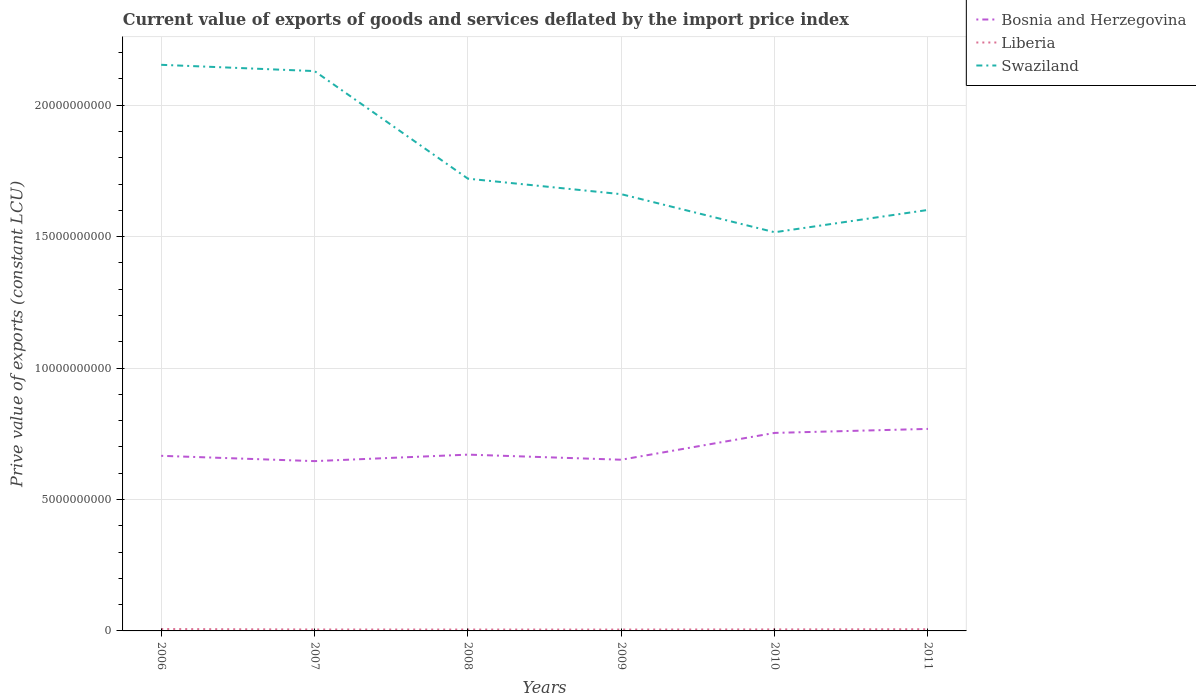How many different coloured lines are there?
Your answer should be compact. 3. Across all years, what is the maximum prive value of exports in Bosnia and Herzegovina?
Keep it short and to the point. 6.46e+09. What is the total prive value of exports in Swaziland in the graph?
Your response must be concise. 6.37e+09. What is the difference between the highest and the second highest prive value of exports in Swaziland?
Ensure brevity in your answer.  6.37e+09. What is the difference between the highest and the lowest prive value of exports in Bosnia and Herzegovina?
Make the answer very short. 2. Is the prive value of exports in Bosnia and Herzegovina strictly greater than the prive value of exports in Liberia over the years?
Provide a short and direct response. No. How many lines are there?
Give a very brief answer. 3. How many years are there in the graph?
Your answer should be very brief. 6. What is the difference between two consecutive major ticks on the Y-axis?
Your answer should be compact. 5.00e+09. Does the graph contain any zero values?
Provide a succinct answer. No. Where does the legend appear in the graph?
Offer a terse response. Top right. How many legend labels are there?
Your answer should be compact. 3. What is the title of the graph?
Your answer should be very brief. Current value of exports of goods and services deflated by the import price index. What is the label or title of the Y-axis?
Provide a succinct answer. Prive value of exports (constant LCU). What is the Prive value of exports (constant LCU) of Bosnia and Herzegovina in 2006?
Ensure brevity in your answer.  6.66e+09. What is the Prive value of exports (constant LCU) in Liberia in 2006?
Offer a terse response. 7.25e+07. What is the Prive value of exports (constant LCU) in Swaziland in 2006?
Provide a short and direct response. 2.15e+1. What is the Prive value of exports (constant LCU) in Bosnia and Herzegovina in 2007?
Offer a very short reply. 6.46e+09. What is the Prive value of exports (constant LCU) in Liberia in 2007?
Make the answer very short. 5.49e+07. What is the Prive value of exports (constant LCU) of Swaziland in 2007?
Offer a very short reply. 2.13e+1. What is the Prive value of exports (constant LCU) in Bosnia and Herzegovina in 2008?
Ensure brevity in your answer.  6.71e+09. What is the Prive value of exports (constant LCU) of Liberia in 2008?
Your response must be concise. 5.26e+07. What is the Prive value of exports (constant LCU) in Swaziland in 2008?
Offer a terse response. 1.72e+1. What is the Prive value of exports (constant LCU) in Bosnia and Herzegovina in 2009?
Keep it short and to the point. 6.51e+09. What is the Prive value of exports (constant LCU) in Liberia in 2009?
Offer a terse response. 5.25e+07. What is the Prive value of exports (constant LCU) of Swaziland in 2009?
Provide a succinct answer. 1.66e+1. What is the Prive value of exports (constant LCU) in Bosnia and Herzegovina in 2010?
Ensure brevity in your answer.  7.53e+09. What is the Prive value of exports (constant LCU) of Liberia in 2010?
Your answer should be very brief. 5.83e+07. What is the Prive value of exports (constant LCU) of Swaziland in 2010?
Keep it short and to the point. 1.52e+1. What is the Prive value of exports (constant LCU) of Bosnia and Herzegovina in 2011?
Make the answer very short. 7.68e+09. What is the Prive value of exports (constant LCU) of Liberia in 2011?
Your response must be concise. 6.47e+07. What is the Prive value of exports (constant LCU) of Swaziland in 2011?
Offer a terse response. 1.60e+1. Across all years, what is the maximum Prive value of exports (constant LCU) in Bosnia and Herzegovina?
Offer a very short reply. 7.68e+09. Across all years, what is the maximum Prive value of exports (constant LCU) of Liberia?
Provide a short and direct response. 7.25e+07. Across all years, what is the maximum Prive value of exports (constant LCU) in Swaziland?
Offer a very short reply. 2.15e+1. Across all years, what is the minimum Prive value of exports (constant LCU) in Bosnia and Herzegovina?
Offer a terse response. 6.46e+09. Across all years, what is the minimum Prive value of exports (constant LCU) of Liberia?
Provide a short and direct response. 5.25e+07. Across all years, what is the minimum Prive value of exports (constant LCU) in Swaziland?
Offer a terse response. 1.52e+1. What is the total Prive value of exports (constant LCU) of Bosnia and Herzegovina in the graph?
Provide a short and direct response. 4.16e+1. What is the total Prive value of exports (constant LCU) in Liberia in the graph?
Your answer should be compact. 3.56e+08. What is the total Prive value of exports (constant LCU) in Swaziland in the graph?
Make the answer very short. 1.08e+11. What is the difference between the Prive value of exports (constant LCU) in Bosnia and Herzegovina in 2006 and that in 2007?
Give a very brief answer. 2.02e+08. What is the difference between the Prive value of exports (constant LCU) in Liberia in 2006 and that in 2007?
Make the answer very short. 1.76e+07. What is the difference between the Prive value of exports (constant LCU) of Swaziland in 2006 and that in 2007?
Make the answer very short. 2.39e+08. What is the difference between the Prive value of exports (constant LCU) in Bosnia and Herzegovina in 2006 and that in 2008?
Provide a short and direct response. -4.52e+07. What is the difference between the Prive value of exports (constant LCU) in Liberia in 2006 and that in 2008?
Your response must be concise. 1.99e+07. What is the difference between the Prive value of exports (constant LCU) in Swaziland in 2006 and that in 2008?
Your answer should be very brief. 4.33e+09. What is the difference between the Prive value of exports (constant LCU) in Bosnia and Herzegovina in 2006 and that in 2009?
Provide a succinct answer. 1.49e+08. What is the difference between the Prive value of exports (constant LCU) in Liberia in 2006 and that in 2009?
Your answer should be very brief. 2.00e+07. What is the difference between the Prive value of exports (constant LCU) in Swaziland in 2006 and that in 2009?
Provide a succinct answer. 4.92e+09. What is the difference between the Prive value of exports (constant LCU) of Bosnia and Herzegovina in 2006 and that in 2010?
Provide a short and direct response. -8.71e+08. What is the difference between the Prive value of exports (constant LCU) of Liberia in 2006 and that in 2010?
Your response must be concise. 1.42e+07. What is the difference between the Prive value of exports (constant LCU) of Swaziland in 2006 and that in 2010?
Provide a succinct answer. 6.37e+09. What is the difference between the Prive value of exports (constant LCU) of Bosnia and Herzegovina in 2006 and that in 2011?
Make the answer very short. -1.02e+09. What is the difference between the Prive value of exports (constant LCU) in Liberia in 2006 and that in 2011?
Provide a short and direct response. 7.83e+06. What is the difference between the Prive value of exports (constant LCU) of Swaziland in 2006 and that in 2011?
Your response must be concise. 5.52e+09. What is the difference between the Prive value of exports (constant LCU) in Bosnia and Herzegovina in 2007 and that in 2008?
Give a very brief answer. -2.48e+08. What is the difference between the Prive value of exports (constant LCU) of Liberia in 2007 and that in 2008?
Your response must be concise. 2.23e+06. What is the difference between the Prive value of exports (constant LCU) of Swaziland in 2007 and that in 2008?
Keep it short and to the point. 4.09e+09. What is the difference between the Prive value of exports (constant LCU) of Bosnia and Herzegovina in 2007 and that in 2009?
Provide a short and direct response. -5.35e+07. What is the difference between the Prive value of exports (constant LCU) in Liberia in 2007 and that in 2009?
Provide a succinct answer. 2.36e+06. What is the difference between the Prive value of exports (constant LCU) of Swaziland in 2007 and that in 2009?
Your answer should be very brief. 4.68e+09. What is the difference between the Prive value of exports (constant LCU) in Bosnia and Herzegovina in 2007 and that in 2010?
Offer a very short reply. -1.07e+09. What is the difference between the Prive value of exports (constant LCU) of Liberia in 2007 and that in 2010?
Give a very brief answer. -3.46e+06. What is the difference between the Prive value of exports (constant LCU) in Swaziland in 2007 and that in 2010?
Give a very brief answer. 6.13e+09. What is the difference between the Prive value of exports (constant LCU) in Bosnia and Herzegovina in 2007 and that in 2011?
Provide a succinct answer. -1.23e+09. What is the difference between the Prive value of exports (constant LCU) in Liberia in 2007 and that in 2011?
Keep it short and to the point. -9.82e+06. What is the difference between the Prive value of exports (constant LCU) in Swaziland in 2007 and that in 2011?
Make the answer very short. 5.28e+09. What is the difference between the Prive value of exports (constant LCU) in Bosnia and Herzegovina in 2008 and that in 2009?
Offer a terse response. 1.94e+08. What is the difference between the Prive value of exports (constant LCU) of Liberia in 2008 and that in 2009?
Your response must be concise. 1.25e+05. What is the difference between the Prive value of exports (constant LCU) in Swaziland in 2008 and that in 2009?
Give a very brief answer. 5.90e+08. What is the difference between the Prive value of exports (constant LCU) of Bosnia and Herzegovina in 2008 and that in 2010?
Your answer should be compact. -8.26e+08. What is the difference between the Prive value of exports (constant LCU) of Liberia in 2008 and that in 2010?
Your answer should be compact. -5.69e+06. What is the difference between the Prive value of exports (constant LCU) in Swaziland in 2008 and that in 2010?
Give a very brief answer. 2.04e+09. What is the difference between the Prive value of exports (constant LCU) in Bosnia and Herzegovina in 2008 and that in 2011?
Ensure brevity in your answer.  -9.78e+08. What is the difference between the Prive value of exports (constant LCU) in Liberia in 2008 and that in 2011?
Your response must be concise. -1.21e+07. What is the difference between the Prive value of exports (constant LCU) in Swaziland in 2008 and that in 2011?
Provide a short and direct response. 1.19e+09. What is the difference between the Prive value of exports (constant LCU) of Bosnia and Herzegovina in 2009 and that in 2010?
Keep it short and to the point. -1.02e+09. What is the difference between the Prive value of exports (constant LCU) of Liberia in 2009 and that in 2010?
Your answer should be very brief. -5.82e+06. What is the difference between the Prive value of exports (constant LCU) of Swaziland in 2009 and that in 2010?
Your response must be concise. 1.45e+09. What is the difference between the Prive value of exports (constant LCU) of Bosnia and Herzegovina in 2009 and that in 2011?
Your response must be concise. -1.17e+09. What is the difference between the Prive value of exports (constant LCU) of Liberia in 2009 and that in 2011?
Provide a succinct answer. -1.22e+07. What is the difference between the Prive value of exports (constant LCU) of Swaziland in 2009 and that in 2011?
Give a very brief answer. 6.00e+08. What is the difference between the Prive value of exports (constant LCU) of Bosnia and Herzegovina in 2010 and that in 2011?
Offer a terse response. -1.52e+08. What is the difference between the Prive value of exports (constant LCU) in Liberia in 2010 and that in 2011?
Provide a succinct answer. -6.36e+06. What is the difference between the Prive value of exports (constant LCU) of Swaziland in 2010 and that in 2011?
Give a very brief answer. -8.48e+08. What is the difference between the Prive value of exports (constant LCU) in Bosnia and Herzegovina in 2006 and the Prive value of exports (constant LCU) in Liberia in 2007?
Keep it short and to the point. 6.61e+09. What is the difference between the Prive value of exports (constant LCU) in Bosnia and Herzegovina in 2006 and the Prive value of exports (constant LCU) in Swaziland in 2007?
Your response must be concise. -1.46e+1. What is the difference between the Prive value of exports (constant LCU) in Liberia in 2006 and the Prive value of exports (constant LCU) in Swaziland in 2007?
Your answer should be very brief. -2.12e+1. What is the difference between the Prive value of exports (constant LCU) in Bosnia and Herzegovina in 2006 and the Prive value of exports (constant LCU) in Liberia in 2008?
Your answer should be compact. 6.61e+09. What is the difference between the Prive value of exports (constant LCU) of Bosnia and Herzegovina in 2006 and the Prive value of exports (constant LCU) of Swaziland in 2008?
Your answer should be compact. -1.05e+1. What is the difference between the Prive value of exports (constant LCU) of Liberia in 2006 and the Prive value of exports (constant LCU) of Swaziland in 2008?
Provide a succinct answer. -1.71e+1. What is the difference between the Prive value of exports (constant LCU) of Bosnia and Herzegovina in 2006 and the Prive value of exports (constant LCU) of Liberia in 2009?
Your answer should be compact. 6.61e+09. What is the difference between the Prive value of exports (constant LCU) of Bosnia and Herzegovina in 2006 and the Prive value of exports (constant LCU) of Swaziland in 2009?
Give a very brief answer. -9.95e+09. What is the difference between the Prive value of exports (constant LCU) of Liberia in 2006 and the Prive value of exports (constant LCU) of Swaziland in 2009?
Ensure brevity in your answer.  -1.65e+1. What is the difference between the Prive value of exports (constant LCU) in Bosnia and Herzegovina in 2006 and the Prive value of exports (constant LCU) in Liberia in 2010?
Your answer should be compact. 6.60e+09. What is the difference between the Prive value of exports (constant LCU) of Bosnia and Herzegovina in 2006 and the Prive value of exports (constant LCU) of Swaziland in 2010?
Your answer should be very brief. -8.50e+09. What is the difference between the Prive value of exports (constant LCU) of Liberia in 2006 and the Prive value of exports (constant LCU) of Swaziland in 2010?
Provide a short and direct response. -1.51e+1. What is the difference between the Prive value of exports (constant LCU) of Bosnia and Herzegovina in 2006 and the Prive value of exports (constant LCU) of Liberia in 2011?
Offer a terse response. 6.60e+09. What is the difference between the Prive value of exports (constant LCU) in Bosnia and Herzegovina in 2006 and the Prive value of exports (constant LCU) in Swaziland in 2011?
Provide a short and direct response. -9.35e+09. What is the difference between the Prive value of exports (constant LCU) of Liberia in 2006 and the Prive value of exports (constant LCU) of Swaziland in 2011?
Your answer should be compact. -1.59e+1. What is the difference between the Prive value of exports (constant LCU) in Bosnia and Herzegovina in 2007 and the Prive value of exports (constant LCU) in Liberia in 2008?
Provide a short and direct response. 6.41e+09. What is the difference between the Prive value of exports (constant LCU) of Bosnia and Herzegovina in 2007 and the Prive value of exports (constant LCU) of Swaziland in 2008?
Give a very brief answer. -1.07e+1. What is the difference between the Prive value of exports (constant LCU) of Liberia in 2007 and the Prive value of exports (constant LCU) of Swaziland in 2008?
Your answer should be compact. -1.71e+1. What is the difference between the Prive value of exports (constant LCU) of Bosnia and Herzegovina in 2007 and the Prive value of exports (constant LCU) of Liberia in 2009?
Your response must be concise. 6.41e+09. What is the difference between the Prive value of exports (constant LCU) of Bosnia and Herzegovina in 2007 and the Prive value of exports (constant LCU) of Swaziland in 2009?
Offer a terse response. -1.02e+1. What is the difference between the Prive value of exports (constant LCU) in Liberia in 2007 and the Prive value of exports (constant LCU) in Swaziland in 2009?
Your response must be concise. -1.66e+1. What is the difference between the Prive value of exports (constant LCU) in Bosnia and Herzegovina in 2007 and the Prive value of exports (constant LCU) in Liberia in 2010?
Your answer should be very brief. 6.40e+09. What is the difference between the Prive value of exports (constant LCU) of Bosnia and Herzegovina in 2007 and the Prive value of exports (constant LCU) of Swaziland in 2010?
Your answer should be compact. -8.71e+09. What is the difference between the Prive value of exports (constant LCU) in Liberia in 2007 and the Prive value of exports (constant LCU) in Swaziland in 2010?
Keep it short and to the point. -1.51e+1. What is the difference between the Prive value of exports (constant LCU) in Bosnia and Herzegovina in 2007 and the Prive value of exports (constant LCU) in Liberia in 2011?
Make the answer very short. 6.39e+09. What is the difference between the Prive value of exports (constant LCU) of Bosnia and Herzegovina in 2007 and the Prive value of exports (constant LCU) of Swaziland in 2011?
Provide a succinct answer. -9.55e+09. What is the difference between the Prive value of exports (constant LCU) in Liberia in 2007 and the Prive value of exports (constant LCU) in Swaziland in 2011?
Offer a terse response. -1.60e+1. What is the difference between the Prive value of exports (constant LCU) of Bosnia and Herzegovina in 2008 and the Prive value of exports (constant LCU) of Liberia in 2009?
Make the answer very short. 6.65e+09. What is the difference between the Prive value of exports (constant LCU) of Bosnia and Herzegovina in 2008 and the Prive value of exports (constant LCU) of Swaziland in 2009?
Your response must be concise. -9.91e+09. What is the difference between the Prive value of exports (constant LCU) of Liberia in 2008 and the Prive value of exports (constant LCU) of Swaziland in 2009?
Provide a short and direct response. -1.66e+1. What is the difference between the Prive value of exports (constant LCU) in Bosnia and Herzegovina in 2008 and the Prive value of exports (constant LCU) in Liberia in 2010?
Provide a succinct answer. 6.65e+09. What is the difference between the Prive value of exports (constant LCU) in Bosnia and Herzegovina in 2008 and the Prive value of exports (constant LCU) in Swaziland in 2010?
Offer a very short reply. -8.46e+09. What is the difference between the Prive value of exports (constant LCU) in Liberia in 2008 and the Prive value of exports (constant LCU) in Swaziland in 2010?
Your answer should be compact. -1.51e+1. What is the difference between the Prive value of exports (constant LCU) of Bosnia and Herzegovina in 2008 and the Prive value of exports (constant LCU) of Liberia in 2011?
Provide a short and direct response. 6.64e+09. What is the difference between the Prive value of exports (constant LCU) in Bosnia and Herzegovina in 2008 and the Prive value of exports (constant LCU) in Swaziland in 2011?
Your answer should be very brief. -9.31e+09. What is the difference between the Prive value of exports (constant LCU) of Liberia in 2008 and the Prive value of exports (constant LCU) of Swaziland in 2011?
Provide a short and direct response. -1.60e+1. What is the difference between the Prive value of exports (constant LCU) in Bosnia and Herzegovina in 2009 and the Prive value of exports (constant LCU) in Liberia in 2010?
Offer a terse response. 6.45e+09. What is the difference between the Prive value of exports (constant LCU) of Bosnia and Herzegovina in 2009 and the Prive value of exports (constant LCU) of Swaziland in 2010?
Make the answer very short. -8.65e+09. What is the difference between the Prive value of exports (constant LCU) in Liberia in 2009 and the Prive value of exports (constant LCU) in Swaziland in 2010?
Your answer should be compact. -1.51e+1. What is the difference between the Prive value of exports (constant LCU) of Bosnia and Herzegovina in 2009 and the Prive value of exports (constant LCU) of Liberia in 2011?
Give a very brief answer. 6.45e+09. What is the difference between the Prive value of exports (constant LCU) of Bosnia and Herzegovina in 2009 and the Prive value of exports (constant LCU) of Swaziland in 2011?
Ensure brevity in your answer.  -9.50e+09. What is the difference between the Prive value of exports (constant LCU) in Liberia in 2009 and the Prive value of exports (constant LCU) in Swaziland in 2011?
Provide a short and direct response. -1.60e+1. What is the difference between the Prive value of exports (constant LCU) in Bosnia and Herzegovina in 2010 and the Prive value of exports (constant LCU) in Liberia in 2011?
Keep it short and to the point. 7.47e+09. What is the difference between the Prive value of exports (constant LCU) of Bosnia and Herzegovina in 2010 and the Prive value of exports (constant LCU) of Swaziland in 2011?
Your answer should be very brief. -8.48e+09. What is the difference between the Prive value of exports (constant LCU) of Liberia in 2010 and the Prive value of exports (constant LCU) of Swaziland in 2011?
Offer a terse response. -1.60e+1. What is the average Prive value of exports (constant LCU) of Bosnia and Herzegovina per year?
Ensure brevity in your answer.  6.93e+09. What is the average Prive value of exports (constant LCU) in Liberia per year?
Your answer should be very brief. 5.93e+07. What is the average Prive value of exports (constant LCU) of Swaziland per year?
Give a very brief answer. 1.80e+1. In the year 2006, what is the difference between the Prive value of exports (constant LCU) in Bosnia and Herzegovina and Prive value of exports (constant LCU) in Liberia?
Your answer should be very brief. 6.59e+09. In the year 2006, what is the difference between the Prive value of exports (constant LCU) in Bosnia and Herzegovina and Prive value of exports (constant LCU) in Swaziland?
Give a very brief answer. -1.49e+1. In the year 2006, what is the difference between the Prive value of exports (constant LCU) in Liberia and Prive value of exports (constant LCU) in Swaziland?
Keep it short and to the point. -2.15e+1. In the year 2007, what is the difference between the Prive value of exports (constant LCU) in Bosnia and Herzegovina and Prive value of exports (constant LCU) in Liberia?
Your answer should be compact. 6.40e+09. In the year 2007, what is the difference between the Prive value of exports (constant LCU) of Bosnia and Herzegovina and Prive value of exports (constant LCU) of Swaziland?
Your response must be concise. -1.48e+1. In the year 2007, what is the difference between the Prive value of exports (constant LCU) of Liberia and Prive value of exports (constant LCU) of Swaziland?
Ensure brevity in your answer.  -2.12e+1. In the year 2008, what is the difference between the Prive value of exports (constant LCU) in Bosnia and Herzegovina and Prive value of exports (constant LCU) in Liberia?
Your answer should be very brief. 6.65e+09. In the year 2008, what is the difference between the Prive value of exports (constant LCU) of Bosnia and Herzegovina and Prive value of exports (constant LCU) of Swaziland?
Offer a terse response. -1.05e+1. In the year 2008, what is the difference between the Prive value of exports (constant LCU) of Liberia and Prive value of exports (constant LCU) of Swaziland?
Keep it short and to the point. -1.72e+1. In the year 2009, what is the difference between the Prive value of exports (constant LCU) in Bosnia and Herzegovina and Prive value of exports (constant LCU) in Liberia?
Offer a terse response. 6.46e+09. In the year 2009, what is the difference between the Prive value of exports (constant LCU) of Bosnia and Herzegovina and Prive value of exports (constant LCU) of Swaziland?
Provide a succinct answer. -1.01e+1. In the year 2009, what is the difference between the Prive value of exports (constant LCU) of Liberia and Prive value of exports (constant LCU) of Swaziland?
Provide a short and direct response. -1.66e+1. In the year 2010, what is the difference between the Prive value of exports (constant LCU) of Bosnia and Herzegovina and Prive value of exports (constant LCU) of Liberia?
Offer a very short reply. 7.47e+09. In the year 2010, what is the difference between the Prive value of exports (constant LCU) of Bosnia and Herzegovina and Prive value of exports (constant LCU) of Swaziland?
Provide a short and direct response. -7.63e+09. In the year 2010, what is the difference between the Prive value of exports (constant LCU) in Liberia and Prive value of exports (constant LCU) in Swaziland?
Your answer should be compact. -1.51e+1. In the year 2011, what is the difference between the Prive value of exports (constant LCU) in Bosnia and Herzegovina and Prive value of exports (constant LCU) in Liberia?
Provide a short and direct response. 7.62e+09. In the year 2011, what is the difference between the Prive value of exports (constant LCU) in Bosnia and Herzegovina and Prive value of exports (constant LCU) in Swaziland?
Keep it short and to the point. -8.33e+09. In the year 2011, what is the difference between the Prive value of exports (constant LCU) in Liberia and Prive value of exports (constant LCU) in Swaziland?
Make the answer very short. -1.59e+1. What is the ratio of the Prive value of exports (constant LCU) in Bosnia and Herzegovina in 2006 to that in 2007?
Provide a succinct answer. 1.03. What is the ratio of the Prive value of exports (constant LCU) of Liberia in 2006 to that in 2007?
Offer a terse response. 1.32. What is the ratio of the Prive value of exports (constant LCU) in Swaziland in 2006 to that in 2007?
Provide a short and direct response. 1.01. What is the ratio of the Prive value of exports (constant LCU) in Bosnia and Herzegovina in 2006 to that in 2008?
Give a very brief answer. 0.99. What is the ratio of the Prive value of exports (constant LCU) of Liberia in 2006 to that in 2008?
Give a very brief answer. 1.38. What is the ratio of the Prive value of exports (constant LCU) in Swaziland in 2006 to that in 2008?
Keep it short and to the point. 1.25. What is the ratio of the Prive value of exports (constant LCU) in Bosnia and Herzegovina in 2006 to that in 2009?
Offer a terse response. 1.02. What is the ratio of the Prive value of exports (constant LCU) of Liberia in 2006 to that in 2009?
Keep it short and to the point. 1.38. What is the ratio of the Prive value of exports (constant LCU) of Swaziland in 2006 to that in 2009?
Your response must be concise. 1.3. What is the ratio of the Prive value of exports (constant LCU) in Bosnia and Herzegovina in 2006 to that in 2010?
Your answer should be compact. 0.88. What is the ratio of the Prive value of exports (constant LCU) in Liberia in 2006 to that in 2010?
Provide a succinct answer. 1.24. What is the ratio of the Prive value of exports (constant LCU) in Swaziland in 2006 to that in 2010?
Your answer should be very brief. 1.42. What is the ratio of the Prive value of exports (constant LCU) of Bosnia and Herzegovina in 2006 to that in 2011?
Make the answer very short. 0.87. What is the ratio of the Prive value of exports (constant LCU) of Liberia in 2006 to that in 2011?
Your response must be concise. 1.12. What is the ratio of the Prive value of exports (constant LCU) of Swaziland in 2006 to that in 2011?
Your response must be concise. 1.34. What is the ratio of the Prive value of exports (constant LCU) of Bosnia and Herzegovina in 2007 to that in 2008?
Your answer should be very brief. 0.96. What is the ratio of the Prive value of exports (constant LCU) of Liberia in 2007 to that in 2008?
Ensure brevity in your answer.  1.04. What is the ratio of the Prive value of exports (constant LCU) in Swaziland in 2007 to that in 2008?
Give a very brief answer. 1.24. What is the ratio of the Prive value of exports (constant LCU) of Bosnia and Herzegovina in 2007 to that in 2009?
Your response must be concise. 0.99. What is the ratio of the Prive value of exports (constant LCU) of Liberia in 2007 to that in 2009?
Offer a terse response. 1.04. What is the ratio of the Prive value of exports (constant LCU) of Swaziland in 2007 to that in 2009?
Give a very brief answer. 1.28. What is the ratio of the Prive value of exports (constant LCU) in Bosnia and Herzegovina in 2007 to that in 2010?
Offer a very short reply. 0.86. What is the ratio of the Prive value of exports (constant LCU) of Liberia in 2007 to that in 2010?
Offer a very short reply. 0.94. What is the ratio of the Prive value of exports (constant LCU) of Swaziland in 2007 to that in 2010?
Ensure brevity in your answer.  1.4. What is the ratio of the Prive value of exports (constant LCU) of Bosnia and Herzegovina in 2007 to that in 2011?
Offer a terse response. 0.84. What is the ratio of the Prive value of exports (constant LCU) of Liberia in 2007 to that in 2011?
Give a very brief answer. 0.85. What is the ratio of the Prive value of exports (constant LCU) of Swaziland in 2007 to that in 2011?
Ensure brevity in your answer.  1.33. What is the ratio of the Prive value of exports (constant LCU) in Bosnia and Herzegovina in 2008 to that in 2009?
Your response must be concise. 1.03. What is the ratio of the Prive value of exports (constant LCU) of Swaziland in 2008 to that in 2009?
Provide a short and direct response. 1.04. What is the ratio of the Prive value of exports (constant LCU) of Bosnia and Herzegovina in 2008 to that in 2010?
Your answer should be compact. 0.89. What is the ratio of the Prive value of exports (constant LCU) of Liberia in 2008 to that in 2010?
Your answer should be compact. 0.9. What is the ratio of the Prive value of exports (constant LCU) in Swaziland in 2008 to that in 2010?
Your answer should be very brief. 1.13. What is the ratio of the Prive value of exports (constant LCU) in Bosnia and Herzegovina in 2008 to that in 2011?
Give a very brief answer. 0.87. What is the ratio of the Prive value of exports (constant LCU) of Liberia in 2008 to that in 2011?
Your response must be concise. 0.81. What is the ratio of the Prive value of exports (constant LCU) in Swaziland in 2008 to that in 2011?
Give a very brief answer. 1.07. What is the ratio of the Prive value of exports (constant LCU) in Bosnia and Herzegovina in 2009 to that in 2010?
Keep it short and to the point. 0.86. What is the ratio of the Prive value of exports (constant LCU) of Liberia in 2009 to that in 2010?
Your response must be concise. 0.9. What is the ratio of the Prive value of exports (constant LCU) in Swaziland in 2009 to that in 2010?
Give a very brief answer. 1.1. What is the ratio of the Prive value of exports (constant LCU) of Bosnia and Herzegovina in 2009 to that in 2011?
Offer a very short reply. 0.85. What is the ratio of the Prive value of exports (constant LCU) of Liberia in 2009 to that in 2011?
Provide a short and direct response. 0.81. What is the ratio of the Prive value of exports (constant LCU) in Swaziland in 2009 to that in 2011?
Provide a succinct answer. 1.04. What is the ratio of the Prive value of exports (constant LCU) of Bosnia and Herzegovina in 2010 to that in 2011?
Make the answer very short. 0.98. What is the ratio of the Prive value of exports (constant LCU) of Liberia in 2010 to that in 2011?
Give a very brief answer. 0.9. What is the ratio of the Prive value of exports (constant LCU) of Swaziland in 2010 to that in 2011?
Provide a short and direct response. 0.95. What is the difference between the highest and the second highest Prive value of exports (constant LCU) of Bosnia and Herzegovina?
Ensure brevity in your answer.  1.52e+08. What is the difference between the highest and the second highest Prive value of exports (constant LCU) of Liberia?
Provide a succinct answer. 7.83e+06. What is the difference between the highest and the second highest Prive value of exports (constant LCU) of Swaziland?
Make the answer very short. 2.39e+08. What is the difference between the highest and the lowest Prive value of exports (constant LCU) in Bosnia and Herzegovina?
Your answer should be compact. 1.23e+09. What is the difference between the highest and the lowest Prive value of exports (constant LCU) in Liberia?
Your response must be concise. 2.00e+07. What is the difference between the highest and the lowest Prive value of exports (constant LCU) of Swaziland?
Keep it short and to the point. 6.37e+09. 